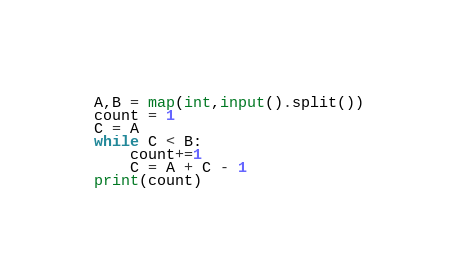Convert code to text. <code><loc_0><loc_0><loc_500><loc_500><_Python_>A,B = map(int,input().split())
count = 1
C = A
while C < B:
    count+=1
    C = A + C - 1
print(count)</code> 